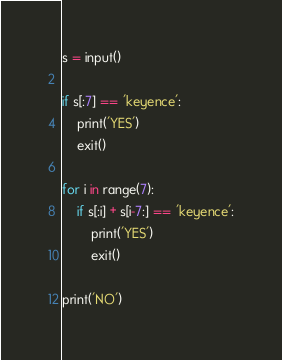Convert code to text. <code><loc_0><loc_0><loc_500><loc_500><_Python_>s = input()

if s[:7] == 'keyence':
	print('YES')
	exit()

for i in range(7):
	if s[:i] + s[i-7:] == 'keyence':
		print('YES')
		exit()

print('NO')</code> 